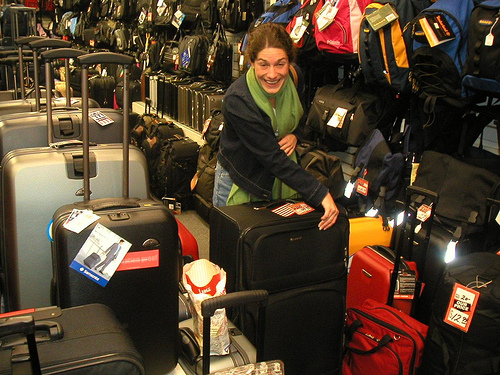Please transcribe the text in this image. 12 